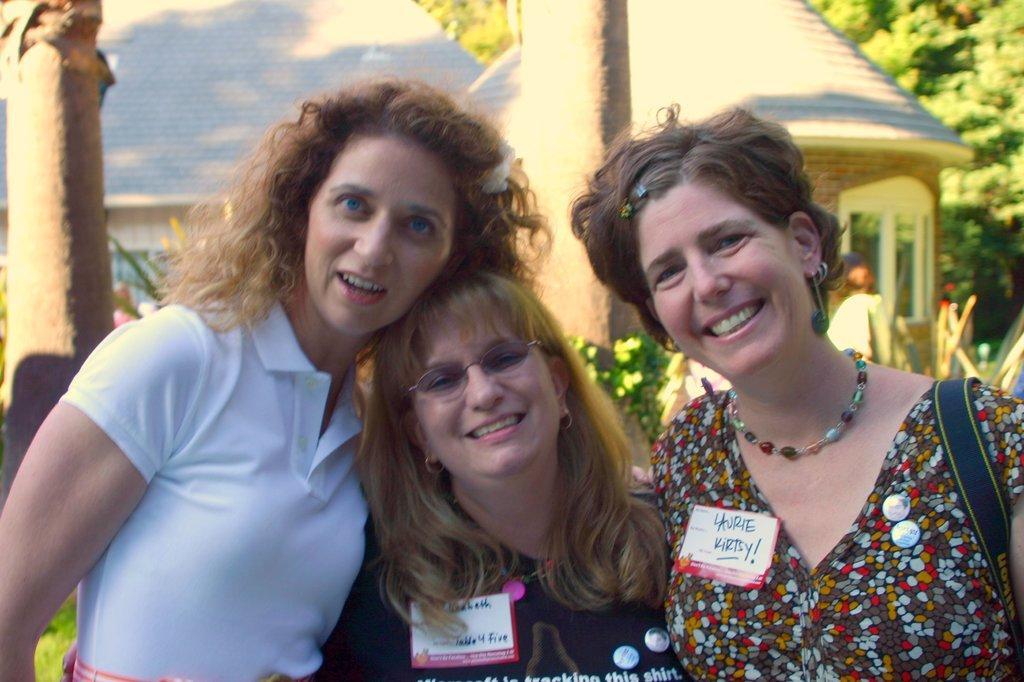Describe this image in one or two sentences. In this image we can see some persons. In the background of the image there are trees, houses, plants and other objects. 